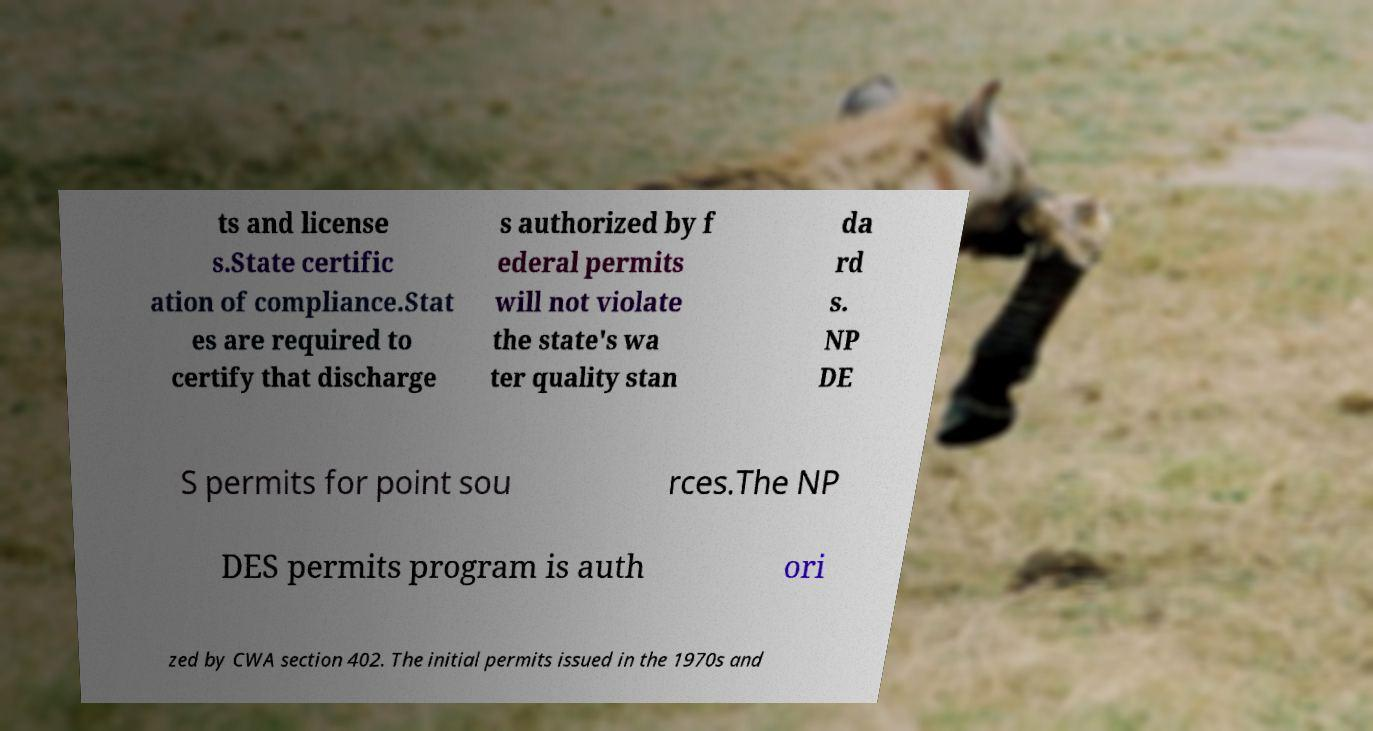Could you extract and type out the text from this image? ts and license s.State certific ation of compliance.Stat es are required to certify that discharge s authorized by f ederal permits will not violate the state's wa ter quality stan da rd s. NP DE S permits for point sou rces.The NP DES permits program is auth ori zed by CWA section 402. The initial permits issued in the 1970s and 